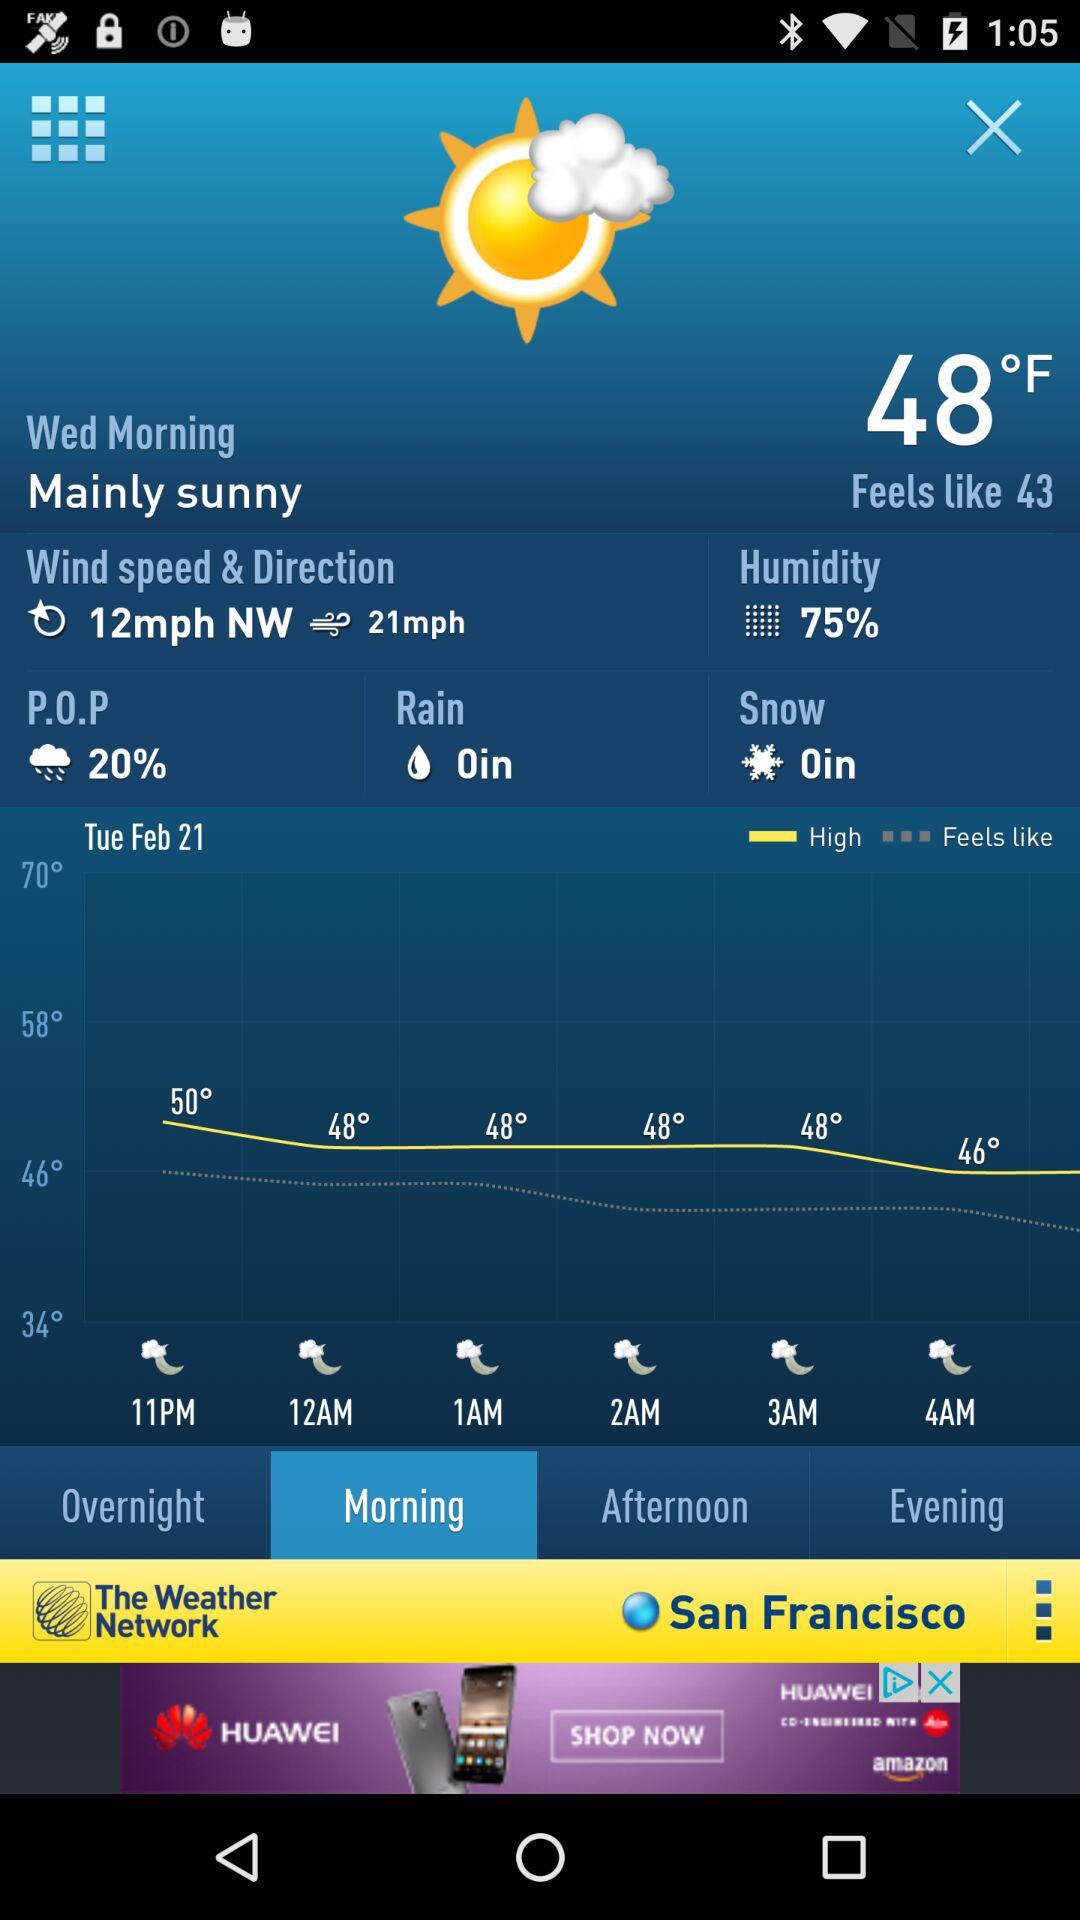What is the temperature on Wednesday morning? The temperature on Wednesday morning is 48 °F. 